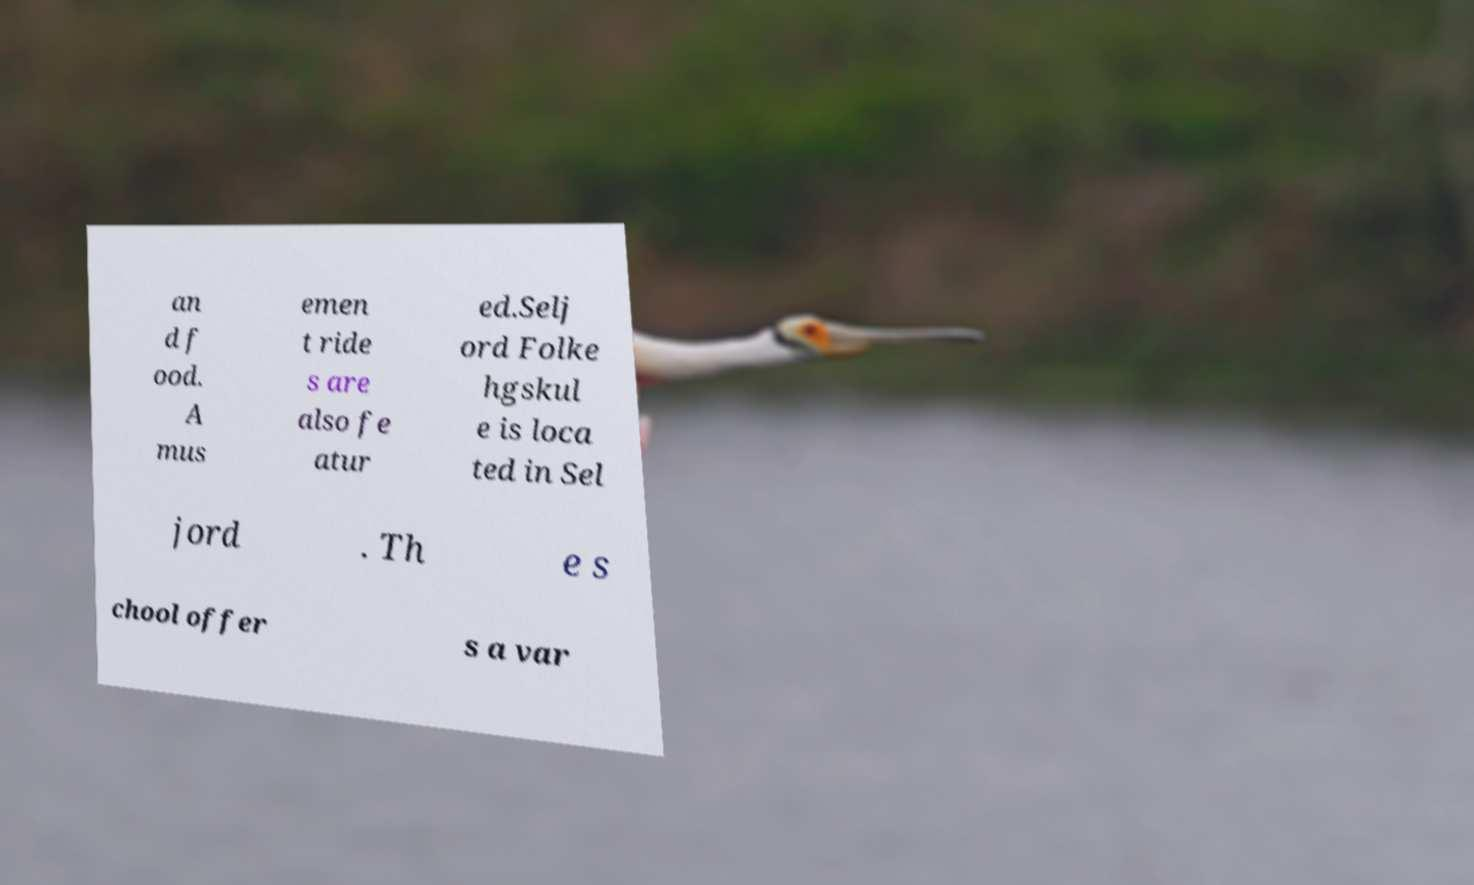I need the written content from this picture converted into text. Can you do that? an d f ood. A mus emen t ride s are also fe atur ed.Selj ord Folke hgskul e is loca ted in Sel jord . Th e s chool offer s a var 